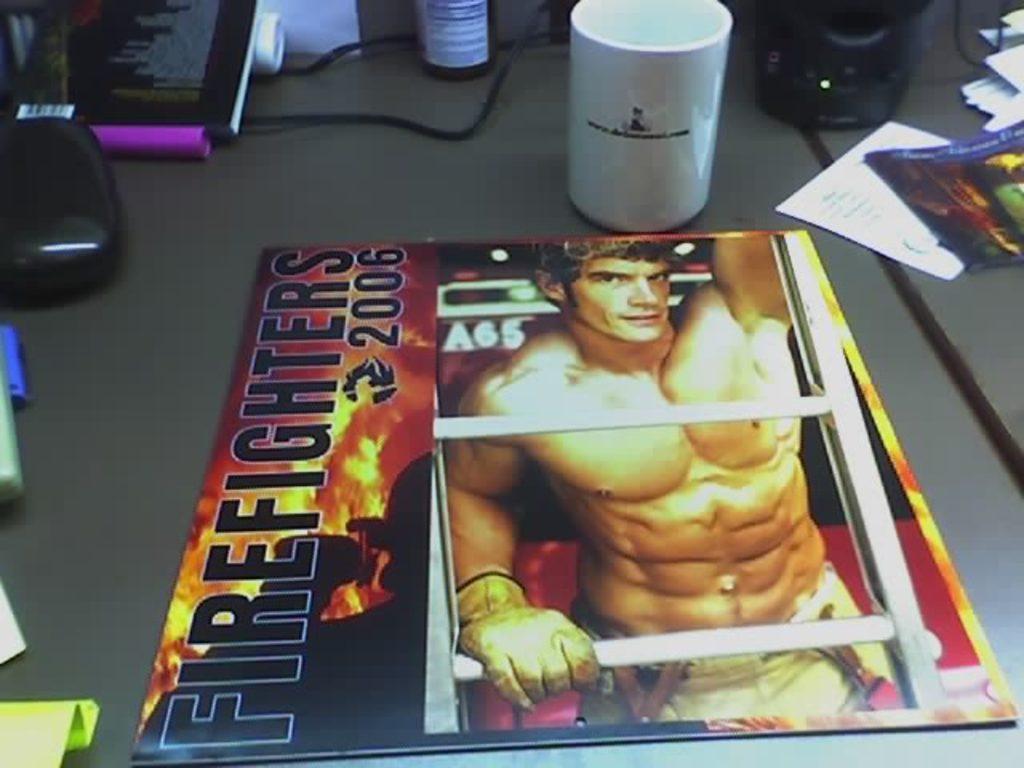In one or two sentences, can you explain what this image depicts? This Image consists of table on which there are mug, book ,bottle, papers, wires. On that book there is written Firefighter 2006 and a person's photo is printed on that book. 